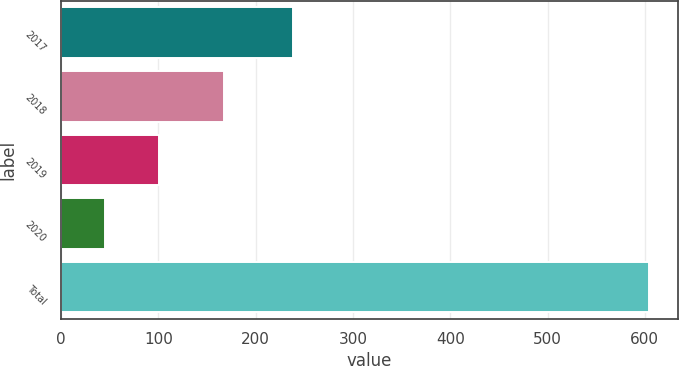Convert chart to OTSL. <chart><loc_0><loc_0><loc_500><loc_500><bar_chart><fcel>2017<fcel>2018<fcel>2019<fcel>2020<fcel>Total<nl><fcel>238<fcel>167<fcel>100.9<fcel>45<fcel>604<nl></chart> 